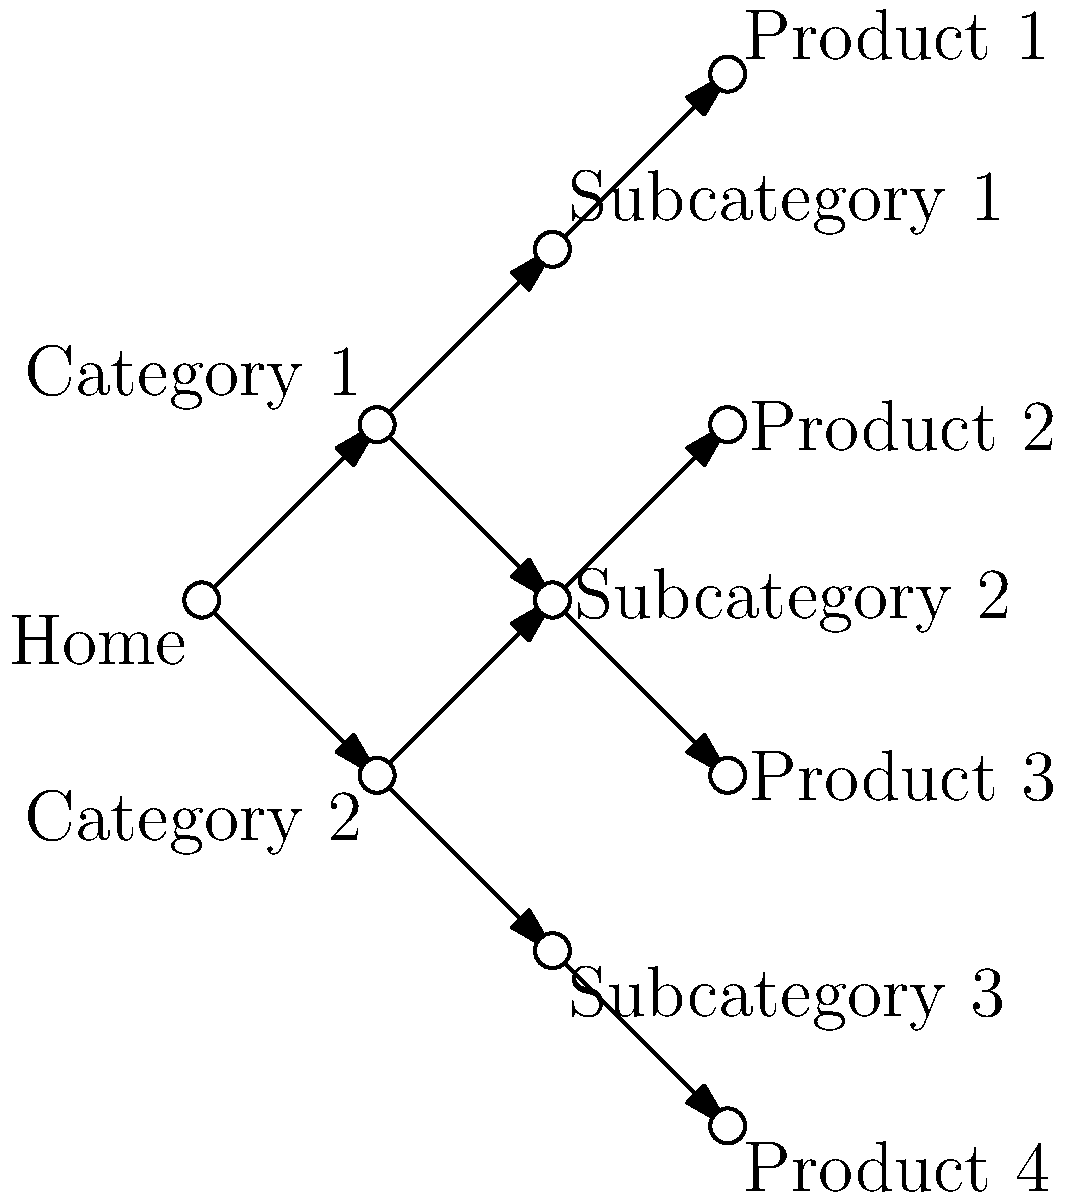Based on the site map diagram, which internal linking structure is most optimal for SEO, and why? To determine the optimal internal linking structure for SEO, we need to consider several factors:

1. Hierarchy: The diagram shows a clear hierarchical structure, which is beneficial for SEO. It starts with the home page at the top, followed by categories, subcategories, and individual product pages.

2. Depth: The structure has a maximum depth of 3 clicks from the home page to the deepest level (product pages). This is ideal for SEO as it ensures that all pages are easily accessible and crawlable by search engines.

3. Internal linking: Each page is connected to at least one other page, creating a well-interlinked structure. This helps distribute link equity throughout the site and aids in crawlability.

4. Siloing: The structure demonstrates content siloing, where related content is grouped together (e.g., Category 1 leads to Subcategory 1 and Product 1). This helps search engines understand the relationship between different pages and topics.

5. Flat architecture: While there is a clear hierarchy, the structure is relatively flat, meaning that important pages are not buried too deep within the site.

6. Home page linking: All main categories are directly linked from the home page, which is crucial for distributing link equity and establishing the importance of these pages.

7. Cross-linking: Subcategory 2 is linked from both Category 1 and Category 2, showing effective cross-linking between different sections of the site.

This structure is optimal for SEO because it balances hierarchy, depth, and interlinking, making it easy for search engines to crawl, understand, and index the site's content efficiently.
Answer: Hierarchical structure with a maximum depth of 3, clear siloing, and effective cross-linking 